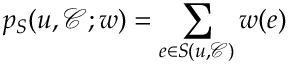<formula> <loc_0><loc_0><loc_500><loc_500>p _ { S } ( u , \mathcal { C } ; w ) = \sum _ { e \in S ( u , \mathcal { C } ) } w ( e )</formula> 